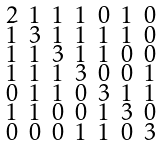Convert formula to latex. <formula><loc_0><loc_0><loc_500><loc_500>\begin{smallmatrix} 2 & 1 & 1 & 1 & 0 & 1 & 0 \\ 1 & 3 & 1 & 1 & 1 & 1 & 0 \\ 1 & 1 & 3 & 1 & 1 & 0 & 0 \\ 1 & 1 & 1 & 3 & 0 & 0 & 1 \\ 0 & 1 & 1 & 0 & 3 & 1 & 1 \\ 1 & 1 & 0 & 0 & 1 & 3 & 0 \\ 0 & 0 & 0 & 1 & 1 & 0 & 3 \end{smallmatrix}</formula> 